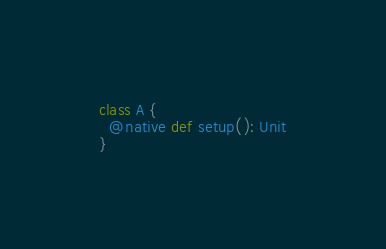<code> <loc_0><loc_0><loc_500><loc_500><_Scala_>class A {
  @native def setup(): Unit
}
</code> 